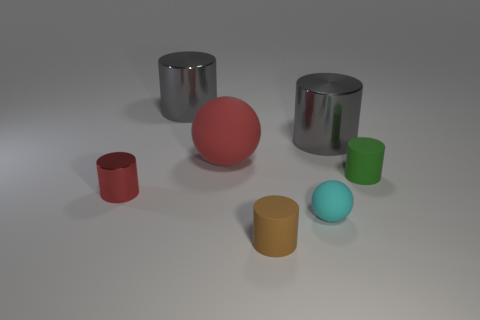What size is the red metallic object?
Your response must be concise. Small. Does the large rubber ball have the same color as the small shiny object?
Your response must be concise. Yes. How many things are yellow blocks or cylinders in front of the cyan ball?
Give a very brief answer. 1. There is a big shiny object right of the gray cylinder that is on the left side of the tiny cyan rubber ball; how many small green things are in front of it?
Ensure brevity in your answer.  1. There is a tiny thing that is the same color as the large rubber object; what material is it?
Give a very brief answer. Metal. What number of large gray objects are there?
Provide a succinct answer. 2. Is the size of the rubber sphere that is on the right side of the red matte sphere the same as the green thing?
Ensure brevity in your answer.  Yes. What number of shiny things are gray objects or yellow cylinders?
Your response must be concise. 2. There is a rubber ball that is right of the red rubber ball; how many tiny green things are in front of it?
Your answer should be compact. 0. There is a rubber object that is both right of the brown thing and behind the small cyan object; what shape is it?
Your answer should be compact. Cylinder. 